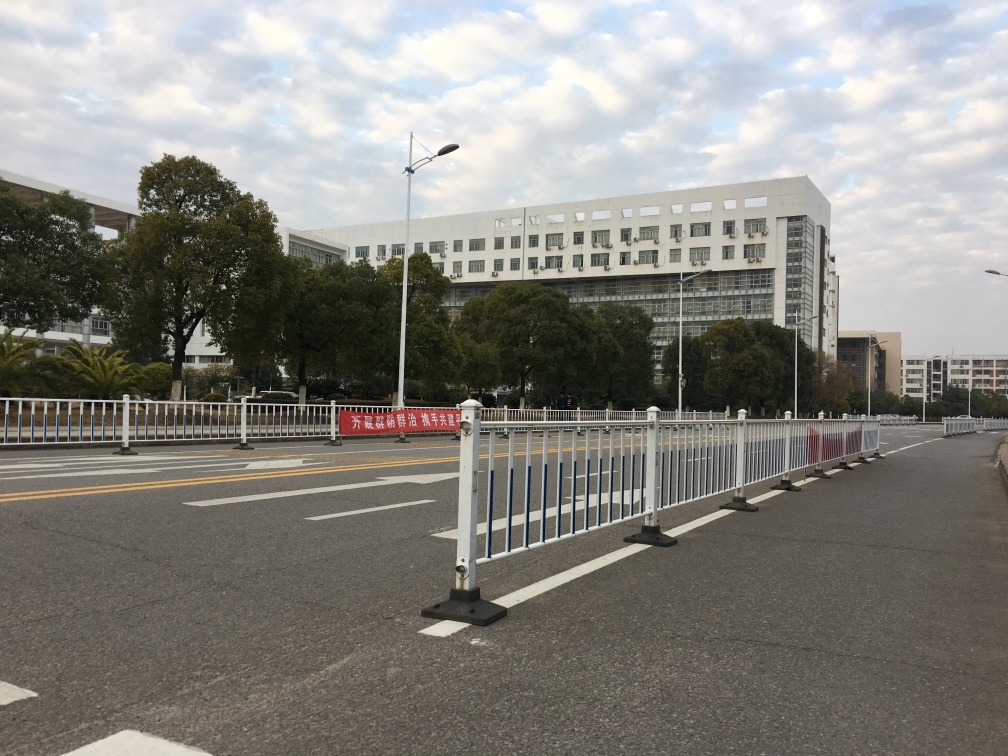What might be the function of the large building in the background? Based on its substantial size and institutional architecture, the building in the background likely serves a significant public or administrative function, such as a governmental office, university, or hospital. 